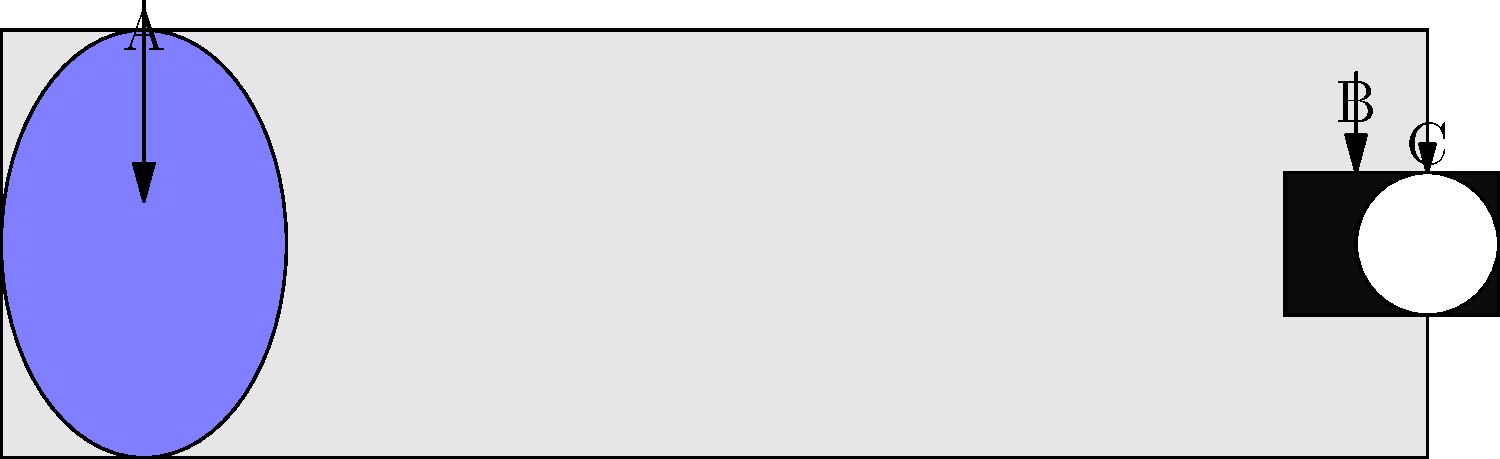As a parent helping your child understand telescopes, identify the parts labeled A, B, and C in the diagram. Which of these is responsible for gathering and focusing light from distant objects? Let's break down the parts of the telescope shown in the diagram:

1. Part A: This is the large lens at the front of the telescope. It's called the objective lens.
2. Part B: This is the focuser, which allows you to adjust the focus of the image.
3. Part C: This is the eyepiece, where you look through to see the magnified image.

The part responsible for gathering and focusing light from distant objects is the objective lens (Part A). Here's why:

1. The objective lens is the largest lens in the telescope.
2. Its primary function is to collect as much light as possible from distant objects.
3. It then focuses this light to form an image inside the telescope tube.
4. The larger the objective lens, the more light it can gather, allowing for brighter and clearer images of faint objects.

The focuser (B) and eyepiece (C) play important roles in refining and magnifying the image, but the initial gathering and focusing of light is done by the objective lens.

Understanding this can help you explain to your child how telescopes work to observe distant celestial objects, which is crucial for their development in astronomy and optics.
Answer: Objective lens (Part A) 